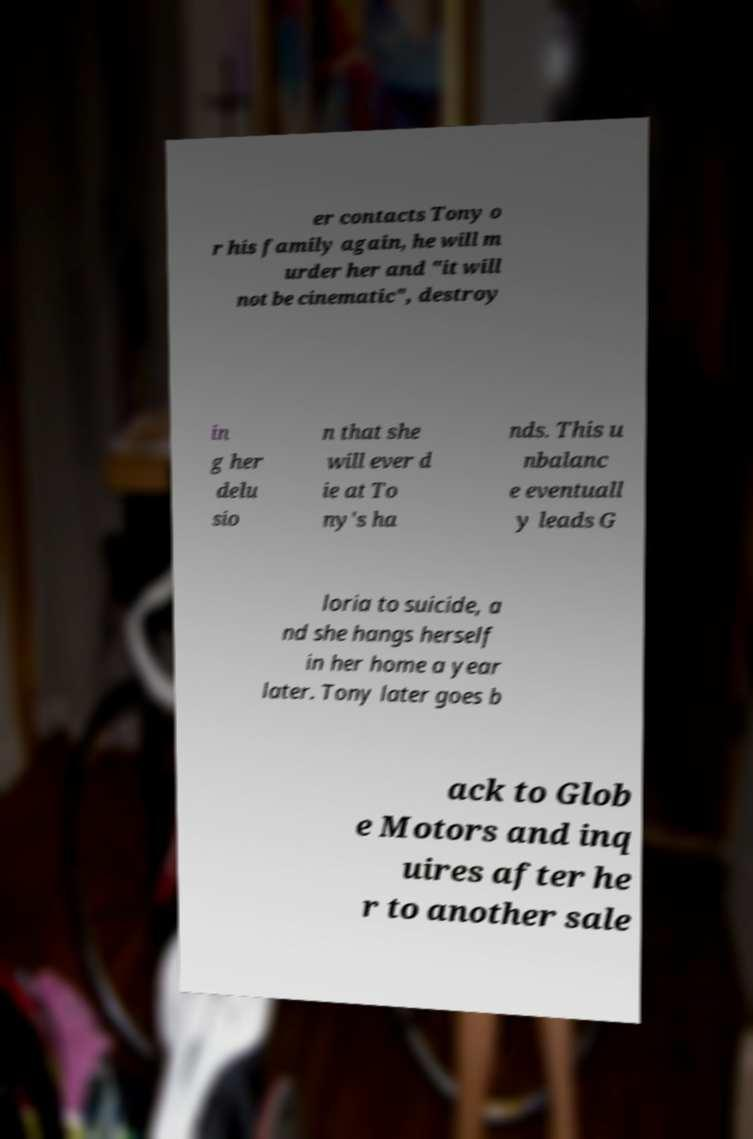Can you read and provide the text displayed in the image?This photo seems to have some interesting text. Can you extract and type it out for me? er contacts Tony o r his family again, he will m urder her and "it will not be cinematic", destroy in g her delu sio n that she will ever d ie at To ny's ha nds. This u nbalanc e eventuall y leads G loria to suicide, a nd she hangs herself in her home a year later. Tony later goes b ack to Glob e Motors and inq uires after he r to another sale 